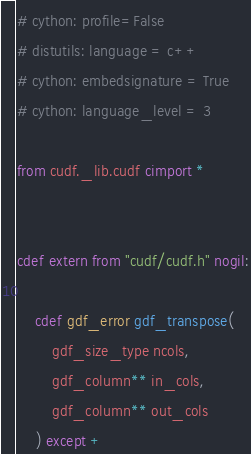Convert code to text. <code><loc_0><loc_0><loc_500><loc_500><_Cython_># cython: profile=False
# distutils: language = c++
# cython: embedsignature = True
# cython: language_level = 3

from cudf._lib.cudf cimport *


cdef extern from "cudf/cudf.h" nogil:

    cdef gdf_error gdf_transpose(
        gdf_size_type ncols,
        gdf_column** in_cols,
        gdf_column** out_cols
    ) except +
</code> 